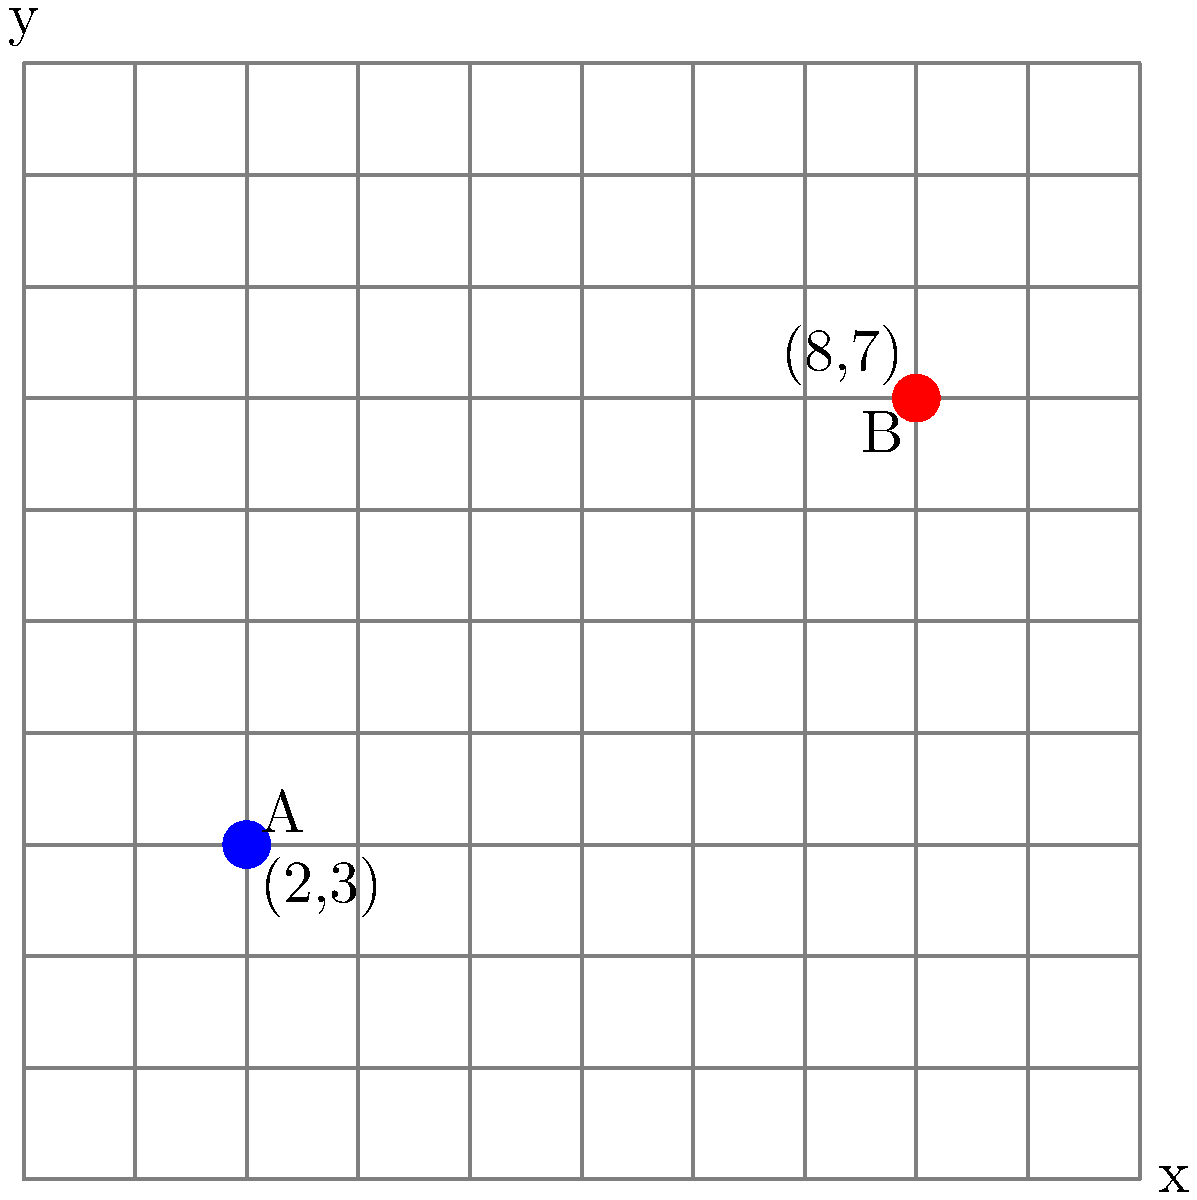In a modern city grid, two newly constructed skyscrapers, A and B, are located at coordinates (2,3) and (8,7) respectively. As an architecture critic, you need to determine the straight-line distance between these two buildings to assess their visual impact on the cityscape. Using the coordinate geometry formula for distance between two points, calculate the distance between skyscrapers A and B. Round your answer to two decimal places. To solve this problem, we'll use the distance formula derived from the Pythagorean theorem:

$$ d = \sqrt{(x_2 - x_1)^2 + (y_2 - y_1)^2} $$

Where $(x_1, y_1)$ are the coordinates of point A and $(x_2, y_2)$ are the coordinates of point B.

Step 1: Identify the coordinates
- Skyscraper A: $(x_1, y_1) = (2, 3)$
- Skyscraper B: $(x_2, y_2) = (8, 7)$

Step 2: Plug the coordinates into the distance formula
$$ d = \sqrt{(8 - 2)^2 + (7 - 3)^2} $$

Step 3: Simplify the expressions inside the parentheses
$$ d = \sqrt{6^2 + 4^2} $$

Step 4: Calculate the squares
$$ d = \sqrt{36 + 16} $$

Step 5: Add the values under the square root
$$ d = \sqrt{52} $$

Step 6: Calculate the square root and round to two decimal places
$$ d \approx 7.21 $$

Therefore, the distance between the two skyscrapers is approximately 7.21 units on the city grid.
Answer: 7.21 units 